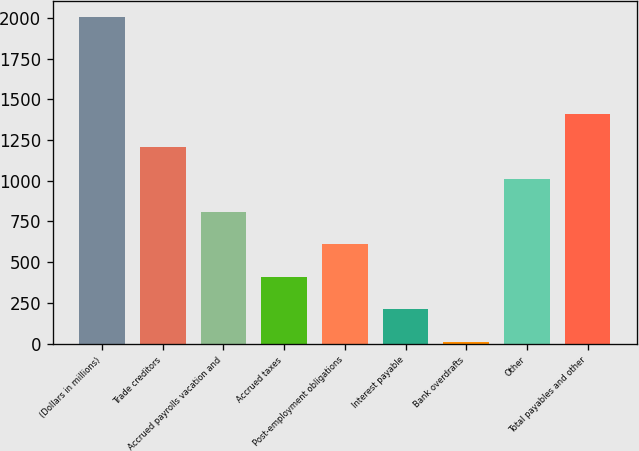Convert chart. <chart><loc_0><loc_0><loc_500><loc_500><bar_chart><fcel>(Dollars in millions)<fcel>Trade creditors<fcel>Accrued payrolls vacation and<fcel>Accrued taxes<fcel>Post-employment obligations<fcel>Interest payable<fcel>Bank overdrafts<fcel>Other<fcel>Total payables and other<nl><fcel>2006<fcel>1208<fcel>809<fcel>410<fcel>609.5<fcel>210.5<fcel>11<fcel>1008.5<fcel>1407.5<nl></chart> 